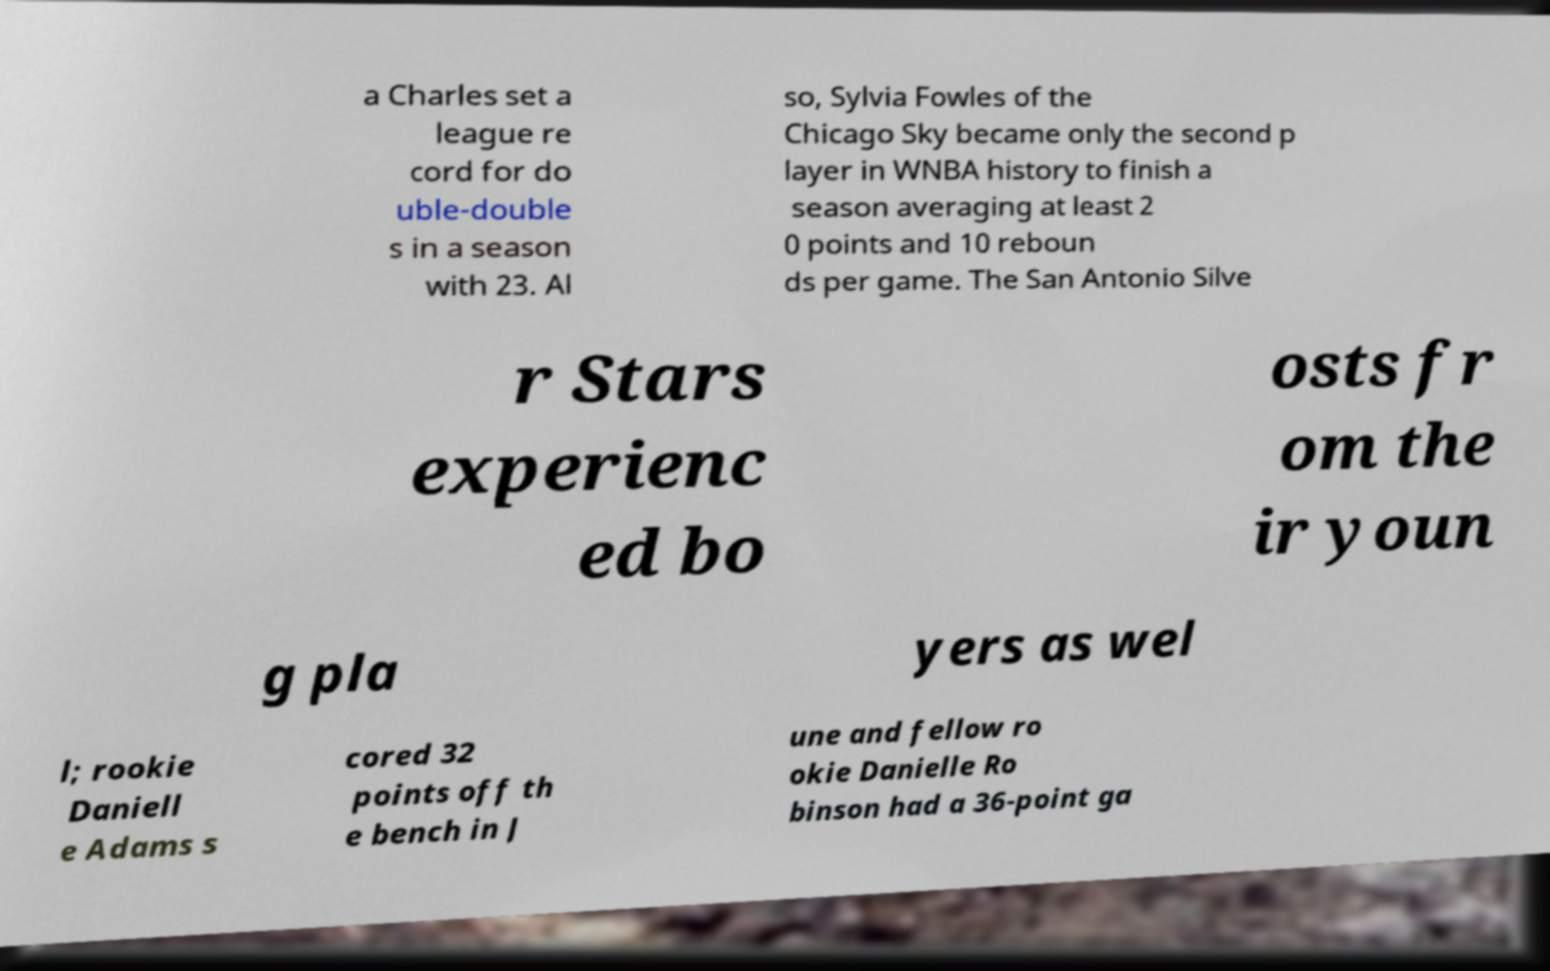Please read and relay the text visible in this image. What does it say? a Charles set a league re cord for do uble-double s in a season with 23. Al so, Sylvia Fowles of the Chicago Sky became only the second p layer in WNBA history to finish a season averaging at least 2 0 points and 10 reboun ds per game. The San Antonio Silve r Stars experienc ed bo osts fr om the ir youn g pla yers as wel l; rookie Daniell e Adams s cored 32 points off th e bench in J une and fellow ro okie Danielle Ro binson had a 36-point ga 